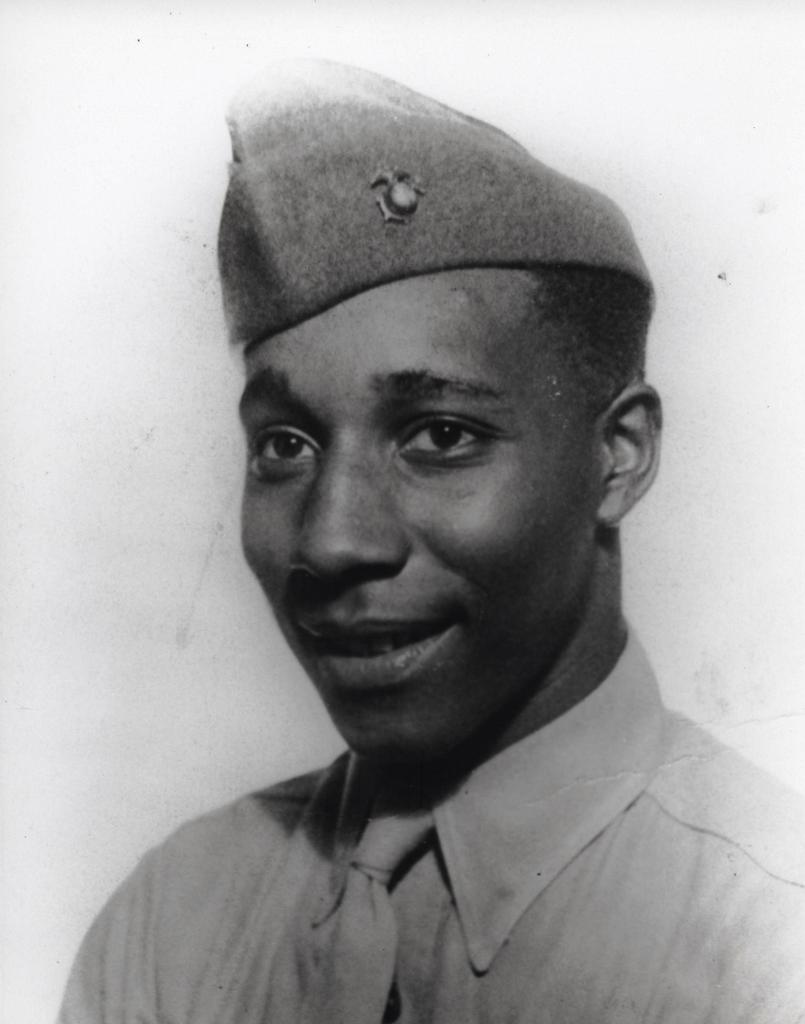Describe this image in one or two sentences. This is a black and white image. A person is present wearing a shirt, tie and a cap. 